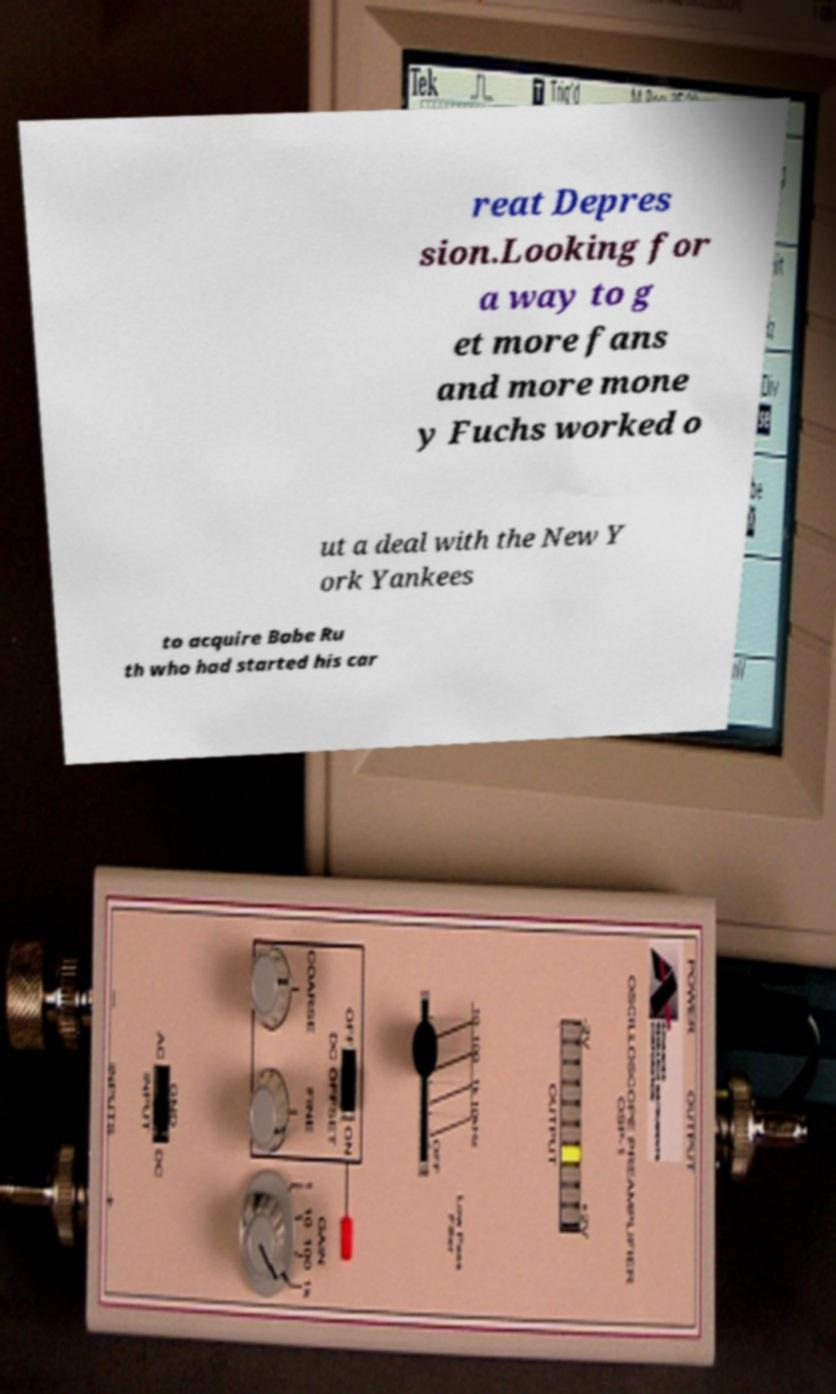Can you read and provide the text displayed in the image?This photo seems to have some interesting text. Can you extract and type it out for me? reat Depres sion.Looking for a way to g et more fans and more mone y Fuchs worked o ut a deal with the New Y ork Yankees to acquire Babe Ru th who had started his car 